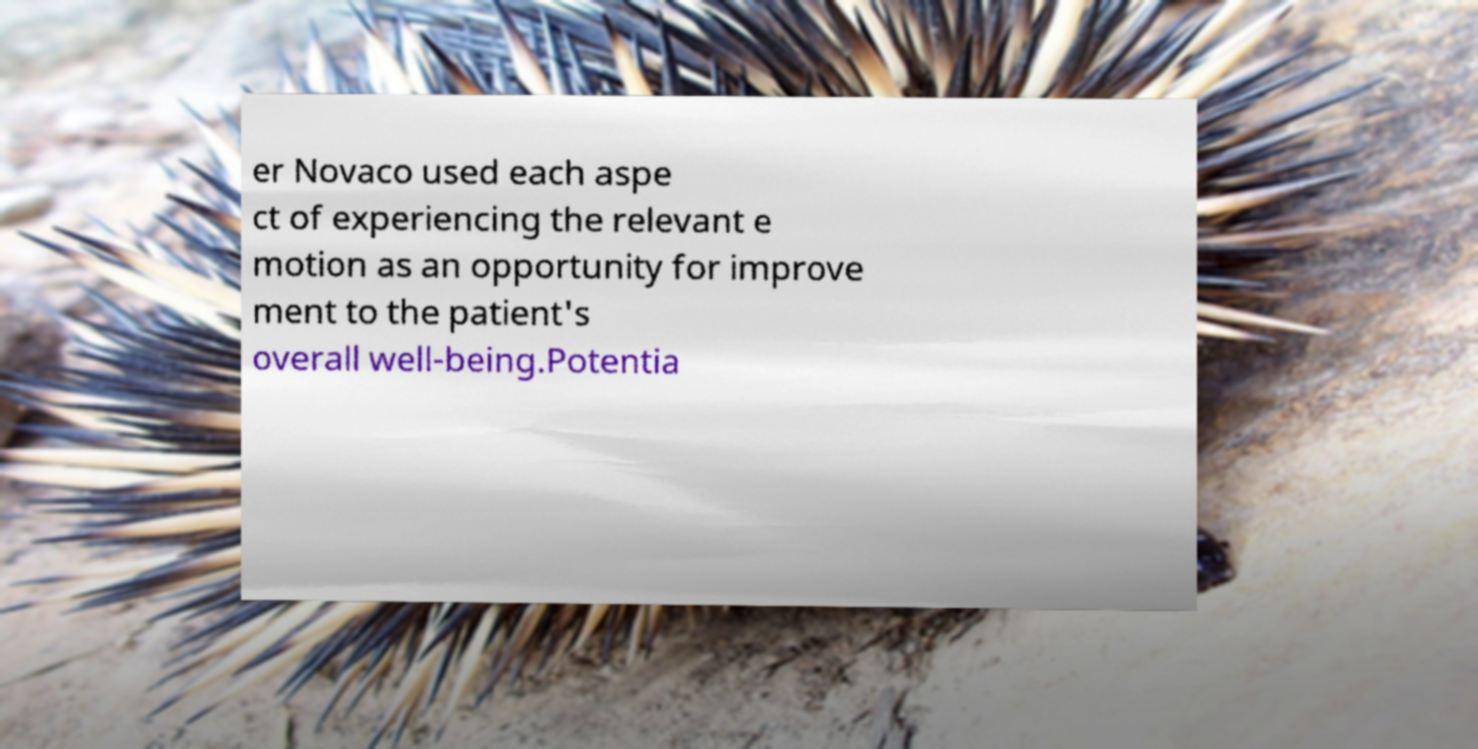I need the written content from this picture converted into text. Can you do that? er Novaco used each aspe ct of experiencing the relevant e motion as an opportunity for improve ment to the patient's overall well-being.Potentia 